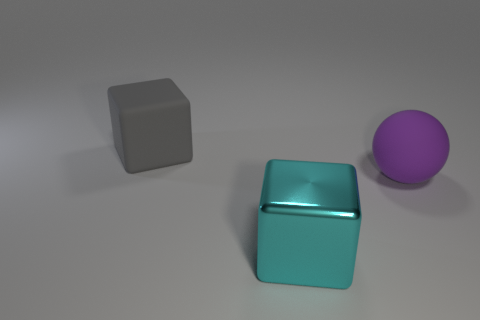Add 3 big purple metallic cubes. How many objects exist? 6 Subtract all cyan blocks. How many blocks are left? 1 Subtract all blocks. How many objects are left? 1 Subtract 1 blocks. How many blocks are left? 1 Subtract all gray balls. Subtract all gray cubes. How many balls are left? 1 Add 3 gray matte cubes. How many gray matte cubes exist? 4 Subtract 0 yellow blocks. How many objects are left? 3 Subtract all cyan cylinders. How many gray cubes are left? 1 Subtract all big yellow balls. Subtract all cyan shiny blocks. How many objects are left? 2 Add 3 purple things. How many purple things are left? 4 